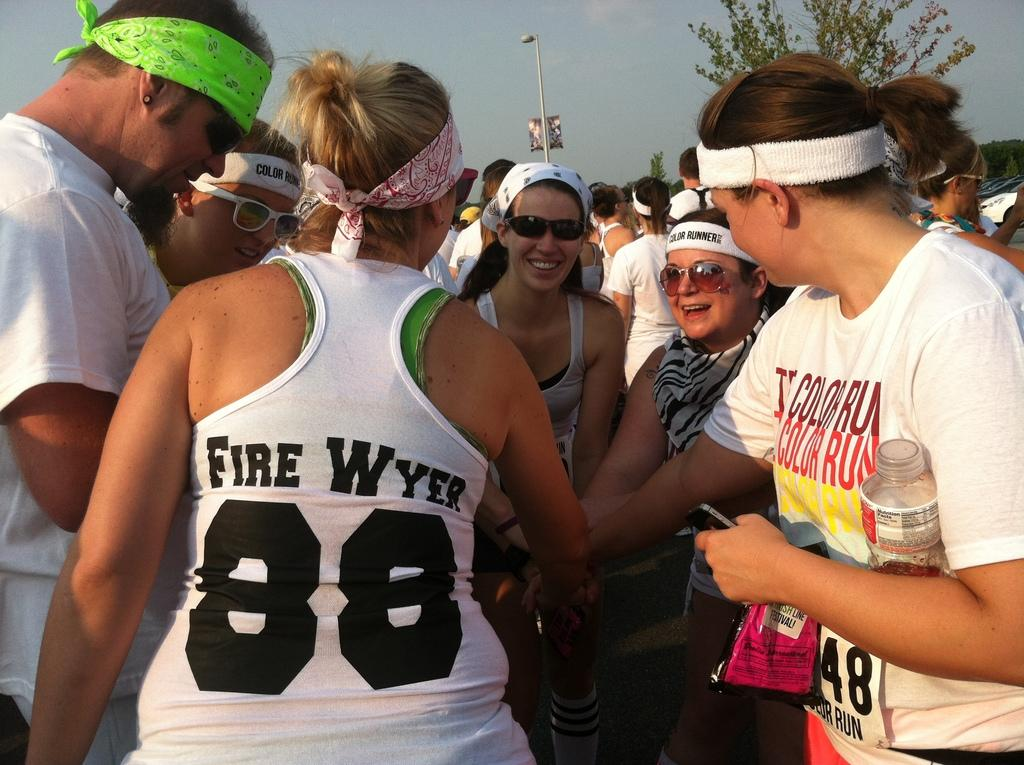<image>
Create a compact narrative representing the image presented. Athlete with a white tank top that has Fire Wyer in black lettering on the back. 